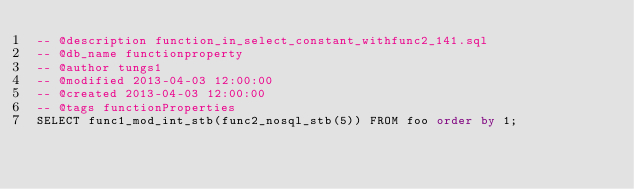<code> <loc_0><loc_0><loc_500><loc_500><_SQL_>-- @description function_in_select_constant_withfunc2_141.sql
-- @db_name functionproperty
-- @author tungs1
-- @modified 2013-04-03 12:00:00
-- @created 2013-04-03 12:00:00
-- @tags functionProperties 
SELECT func1_mod_int_stb(func2_nosql_stb(5)) FROM foo order by 1; 
</code> 